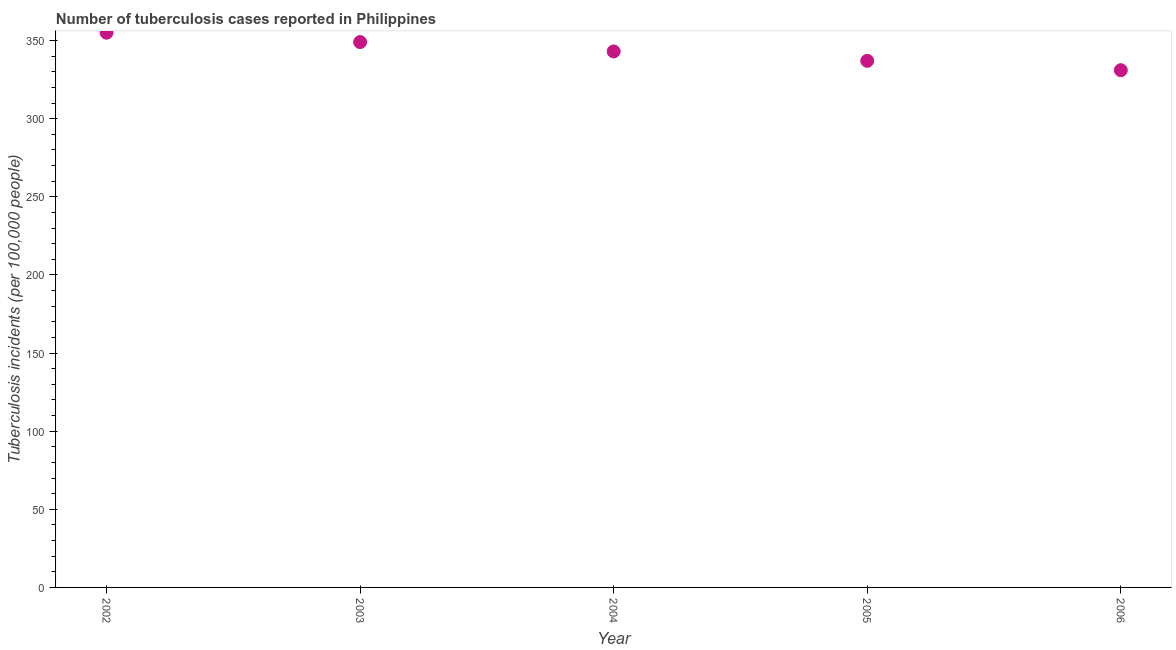What is the number of tuberculosis incidents in 2002?
Provide a succinct answer. 355. Across all years, what is the maximum number of tuberculosis incidents?
Your answer should be very brief. 355. Across all years, what is the minimum number of tuberculosis incidents?
Ensure brevity in your answer.  331. In which year was the number of tuberculosis incidents minimum?
Make the answer very short. 2006. What is the sum of the number of tuberculosis incidents?
Your answer should be compact. 1715. What is the difference between the number of tuberculosis incidents in 2002 and 2005?
Keep it short and to the point. 18. What is the average number of tuberculosis incidents per year?
Offer a terse response. 343. What is the median number of tuberculosis incidents?
Provide a succinct answer. 343. In how many years, is the number of tuberculosis incidents greater than 70 ?
Provide a short and direct response. 5. What is the ratio of the number of tuberculosis incidents in 2002 to that in 2005?
Your response must be concise. 1.05. Is the number of tuberculosis incidents in 2004 less than that in 2005?
Make the answer very short. No. What is the difference between the highest and the second highest number of tuberculosis incidents?
Ensure brevity in your answer.  6. What is the difference between the highest and the lowest number of tuberculosis incidents?
Offer a terse response. 24. Does the number of tuberculosis incidents monotonically increase over the years?
Provide a succinct answer. No. How many dotlines are there?
Your answer should be compact. 1. How many years are there in the graph?
Provide a short and direct response. 5. What is the difference between two consecutive major ticks on the Y-axis?
Make the answer very short. 50. Are the values on the major ticks of Y-axis written in scientific E-notation?
Give a very brief answer. No. What is the title of the graph?
Ensure brevity in your answer.  Number of tuberculosis cases reported in Philippines. What is the label or title of the X-axis?
Ensure brevity in your answer.  Year. What is the label or title of the Y-axis?
Provide a succinct answer. Tuberculosis incidents (per 100,0 people). What is the Tuberculosis incidents (per 100,000 people) in 2002?
Keep it short and to the point. 355. What is the Tuberculosis incidents (per 100,000 people) in 2003?
Offer a very short reply. 349. What is the Tuberculosis incidents (per 100,000 people) in 2004?
Provide a short and direct response. 343. What is the Tuberculosis incidents (per 100,000 people) in 2005?
Provide a succinct answer. 337. What is the Tuberculosis incidents (per 100,000 people) in 2006?
Give a very brief answer. 331. What is the difference between the Tuberculosis incidents (per 100,000 people) in 2002 and 2003?
Make the answer very short. 6. What is the difference between the Tuberculosis incidents (per 100,000 people) in 2002 and 2005?
Make the answer very short. 18. What is the difference between the Tuberculosis incidents (per 100,000 people) in 2004 and 2005?
Keep it short and to the point. 6. What is the ratio of the Tuberculosis incidents (per 100,000 people) in 2002 to that in 2004?
Give a very brief answer. 1.03. What is the ratio of the Tuberculosis incidents (per 100,000 people) in 2002 to that in 2005?
Give a very brief answer. 1.05. What is the ratio of the Tuberculosis incidents (per 100,000 people) in 2002 to that in 2006?
Make the answer very short. 1.07. What is the ratio of the Tuberculosis incidents (per 100,000 people) in 2003 to that in 2005?
Provide a succinct answer. 1.04. What is the ratio of the Tuberculosis incidents (per 100,000 people) in 2003 to that in 2006?
Your response must be concise. 1.05. What is the ratio of the Tuberculosis incidents (per 100,000 people) in 2004 to that in 2005?
Provide a succinct answer. 1.02. What is the ratio of the Tuberculosis incidents (per 100,000 people) in 2004 to that in 2006?
Provide a short and direct response. 1.04. 